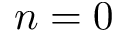Convert formula to latex. <formula><loc_0><loc_0><loc_500><loc_500>n = 0</formula> 